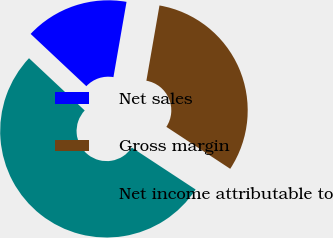<chart> <loc_0><loc_0><loc_500><loc_500><pie_chart><fcel>Net sales<fcel>Gross margin<fcel>Net income attributable to<nl><fcel>15.75%<fcel>31.51%<fcel>52.74%<nl></chart> 